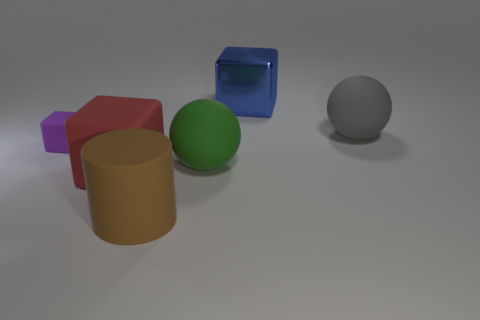What number of things are either large rubber objects that are behind the purple rubber thing or rubber balls behind the green rubber object?
Keep it short and to the point. 1. The object that is in front of the big cube in front of the large blue metallic object is what shape?
Ensure brevity in your answer.  Cylinder. Are there any big objects that have the same material as the brown cylinder?
Provide a succinct answer. Yes. There is a large metallic thing that is the same shape as the tiny purple rubber object; what color is it?
Give a very brief answer. Blue. Is the number of big brown rubber cylinders that are behind the brown thing less than the number of purple matte cubes right of the purple block?
Offer a very short reply. No. How many other objects are the same shape as the large brown thing?
Provide a short and direct response. 0. Is the number of brown rubber things behind the tiny rubber block less than the number of blue objects?
Keep it short and to the point. Yes. There is a large block that is in front of the small thing; what is its material?
Your answer should be very brief. Rubber. What number of other things are there of the same size as the red rubber cube?
Provide a succinct answer. 4. Is the number of blue objects less than the number of big things?
Offer a very short reply. Yes. 